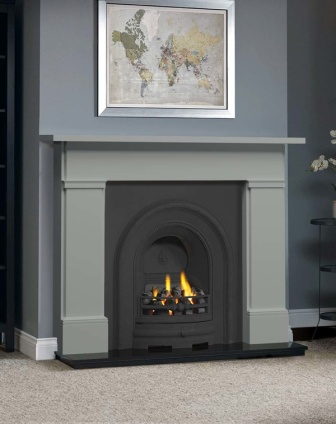How does the design of the fireplace influence the atmosphere of the room? The classic Victorian design of the fireplace, with its elegant arch and detailed moldings, enhances the room by adding a sense of historical charm and sophistication. The warmth of the fire itself introduces a cozy, inviting atmosphere, making the space ideal for relaxation or intimate gatherings. The gray color scheme helps maintain a modern feel, ensuring that the historic elements blend smoothly with contemporary aesthetics. 